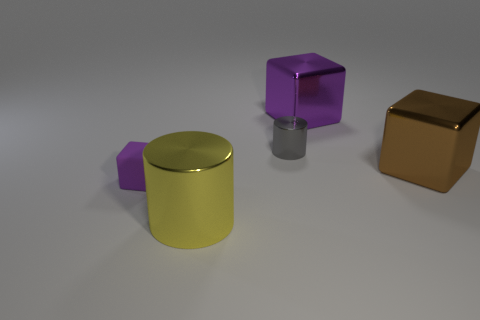Add 2 tiny matte objects. How many objects exist? 7 Subtract all cubes. How many objects are left? 2 Add 2 yellow cylinders. How many yellow cylinders are left? 3 Add 5 large blocks. How many large blocks exist? 7 Subtract 0 red balls. How many objects are left? 5 Subtract all big purple metal things. Subtract all big brown shiny cylinders. How many objects are left? 4 